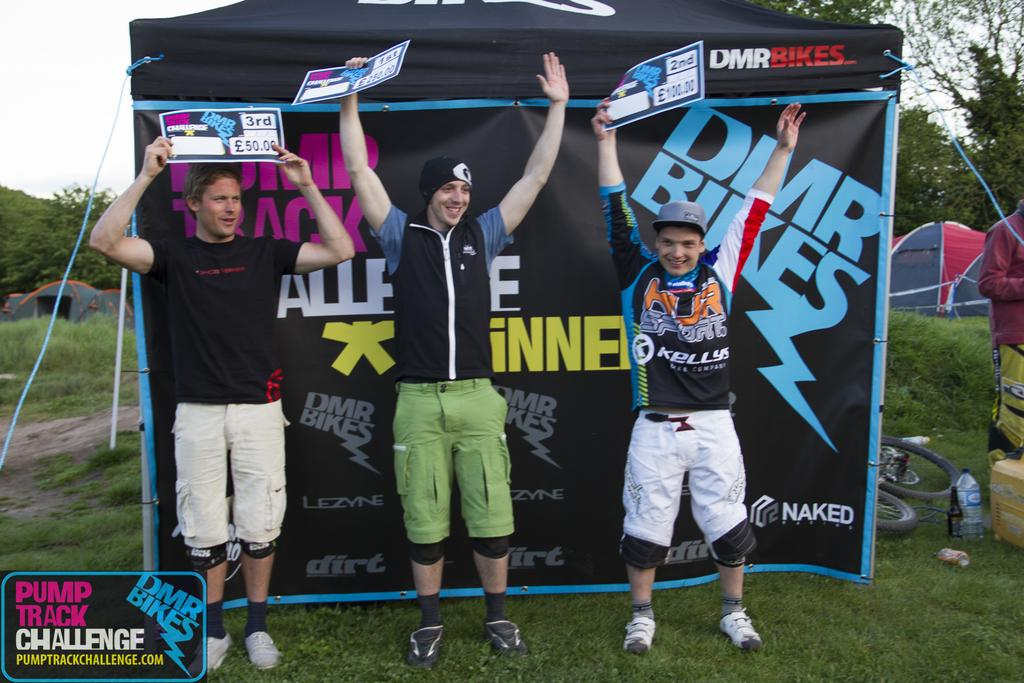<image>
Share a concise interpretation of the image provided. a man next to a pump truck challenge logo on the left 